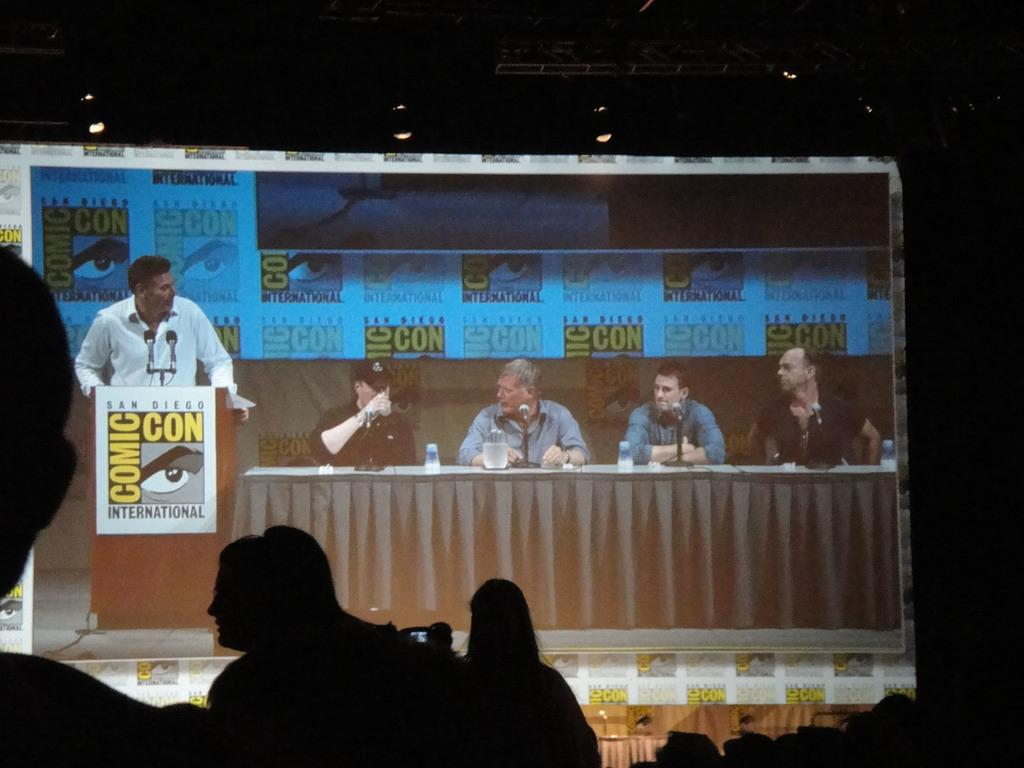How many people are in the image? There are people in the image, but the exact number is not specified. What type of furniture is present in the image? There is at least one table in the image. What is hanging or displayed in the image? There is a banner in the image. What device is used for amplifying sound in the image? There is a microphone (mic) in the image. What are some people doing in the image? Some people are sitting on chairs. What objects are on the tables in the image? There are mice and glasses on the tables. What type of engine can be seen powering the mice in the image? There are no engines present in the image, and the mice are not powered by any engine. 